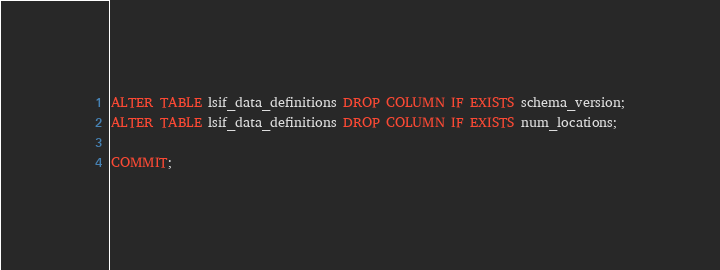Convert code to text. <code><loc_0><loc_0><loc_500><loc_500><_SQL_>ALTER TABLE lsif_data_definitions DROP COLUMN IF EXISTS schema_version;
ALTER TABLE lsif_data_definitions DROP COLUMN IF EXISTS num_locations;

COMMIT;
</code> 